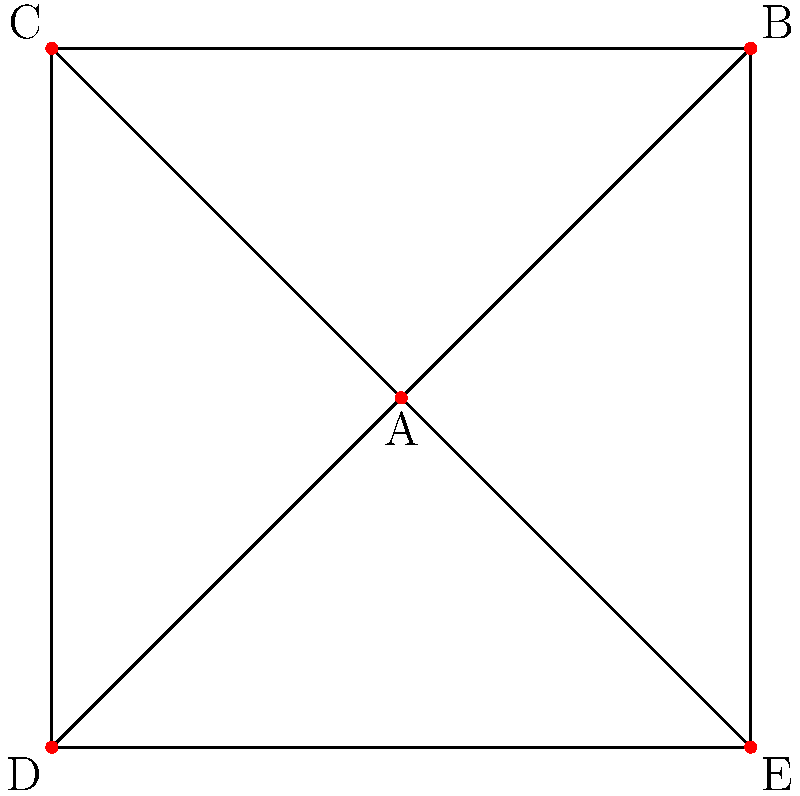In the context of social media influence networks, consider the graph above representing a network of influencers (nodes) and their connections (edges). Node A has a centrality of 1.0, while all other nodes have a centrality of 0.75. What ethical concern does this network structure raise, and how might it impact the spread of information or misinformation? To answer this question, let's analyze the network structure and its implications step by step:

1. Network structure:
   - The graph shows a star-like configuration with node A at the center.
   - Node A is directly connected to all other nodes (B, C, D, E).
   - The peripheral nodes (B, C, D, E) are connected to their adjacent nodes, forming a ring.

2. Centrality values:
   - Node A has the highest centrality (1.0), indicating it's the most influential node.
   - All other nodes have equal, lower centrality (0.75).

3. Implications of this structure:
   - Node A has direct access to all other nodes, making it a powerful information hub.
   - Information originating from A can quickly reach all other nodes.
   - A can control the flow of information between disconnected nodes (e.g., B and D).

4. Ethical concerns:
   - Power concentration: Node A has disproportionate influence over the network.
   - Information monopoly: A can potentially manipulate or filter information.
   - Lack of diversity: The network relies heavily on a single source.

5. Impact on information/misinformation spread:
   - Rapid dissemination: Information from A can spread quickly throughout the network.
   - Limited fact-checking: Other nodes may not have alternative sources to verify information from A.
   - Amplification effect: If A spreads misinformation, it could be quickly adopted by the entire network.

6. Ethical implications for persuasive technology:
   - The structure could be exploited to maximize influence, potentially manipulating users.
   - It raises questions about the responsibility of central nodes in information dissemination.
   - There's a need for transparency about network structures in social media platforms.

The main ethical concern is the concentration of influence in a single node, which could lead to information control and manipulation, potentially facilitating the spread of misinformation.
Answer: Centralization of influence, leading to potential information manipulation and rapid misinformation spread. 